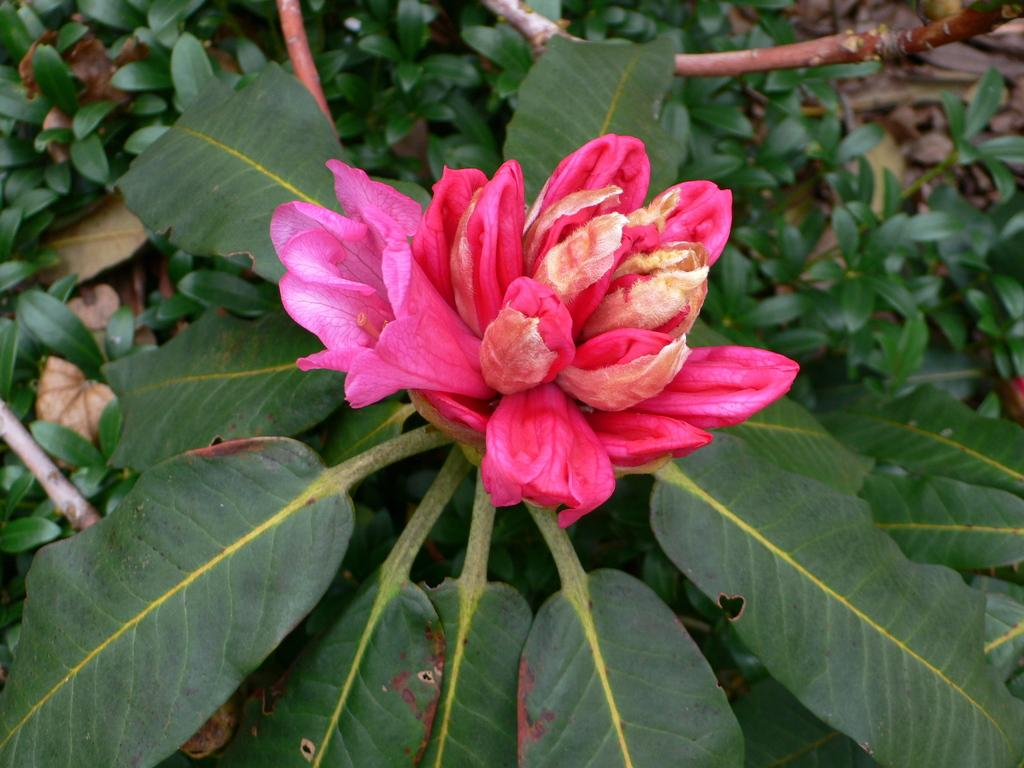What is present in the image? There is a plant in the image. Can you describe the plant's flower? The plant has a pink flower. What else can be seen in the background of the image? There are plants in the background of the image. What is the taste of the fifth plant in the image? There is no mention of a fifth plant in the image, nor is there any information about the taste of any plant. 